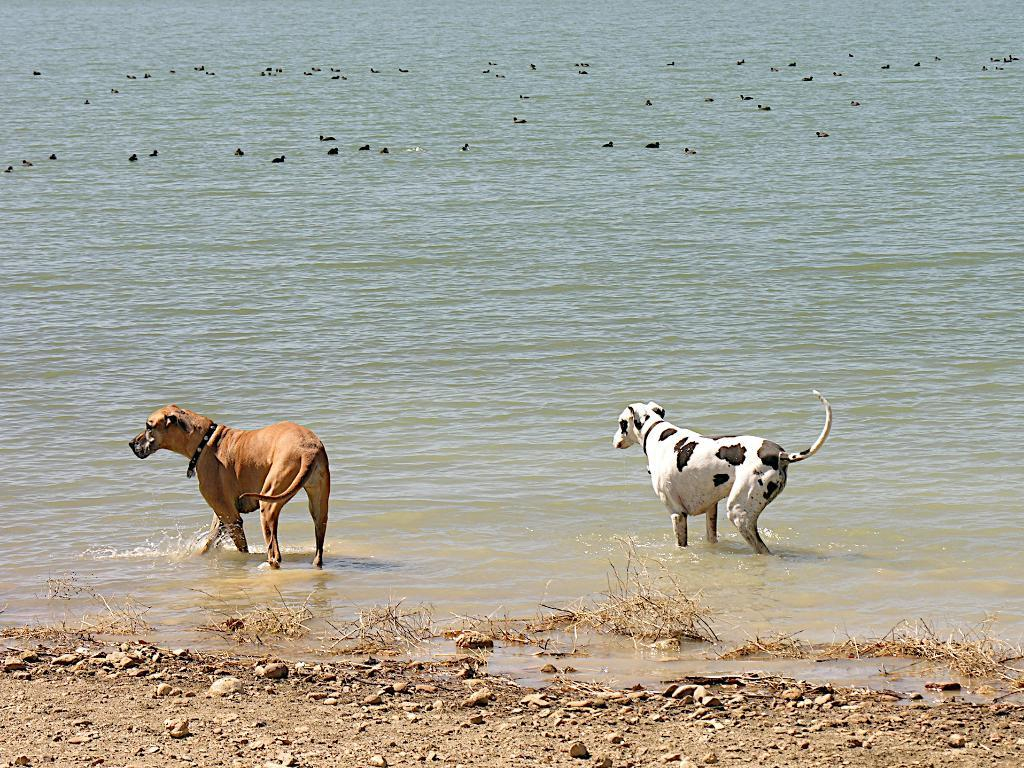What type of dog can be seen in the image? There is a dalmatian dog and a gold-colored dog in the image. What are the dogs doing in the image? Both dogs are walking in the water. What else can be seen in the water in the image? There are other animals swimming in the water. What is visible on the ground in the image? There are stones visible in the image. How many toes does the dalmatian dog have on its front paw in the image? The number of toes on the dalmatian dog's front paw cannot be determined from the image. 